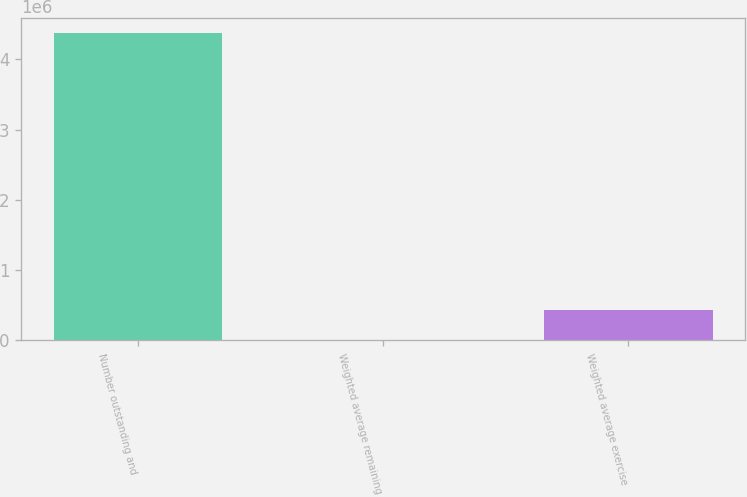<chart> <loc_0><loc_0><loc_500><loc_500><bar_chart><fcel>Number outstanding and<fcel>Weighted average remaining<fcel>Weighted average exercise<nl><fcel>4.37168e+06<fcel>0.8<fcel>437169<nl></chart> 